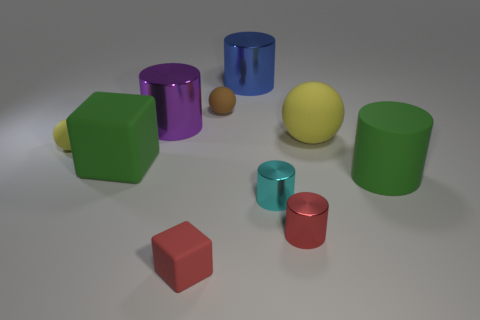There is a small sphere to the right of the yellow matte ball left of the tiny cyan shiny thing; what number of spheres are in front of it?
Provide a short and direct response. 2. There is a large object that is both in front of the tiny yellow matte ball and right of the small brown matte object; what material is it?
Offer a terse response. Rubber. What is the color of the small rubber block?
Provide a short and direct response. Red. Is the number of tiny brown spheres that are to the left of the purple object greater than the number of yellow spheres left of the cyan metallic cylinder?
Offer a terse response. No. There is a large rubber thing left of the small red shiny thing; what color is it?
Provide a short and direct response. Green. Does the yellow sphere that is on the right side of the tiny red matte cube have the same size as the rubber ball to the left of the brown thing?
Offer a very short reply. No. How many things are either small cyan metallic things or blue matte objects?
Offer a very short reply. 1. What material is the ball that is in front of the yellow rubber object that is to the right of the cyan shiny cylinder?
Your response must be concise. Rubber. What number of large green rubber objects have the same shape as the red shiny thing?
Keep it short and to the point. 1. Are there any big shiny things that have the same color as the small matte block?
Keep it short and to the point. No. 